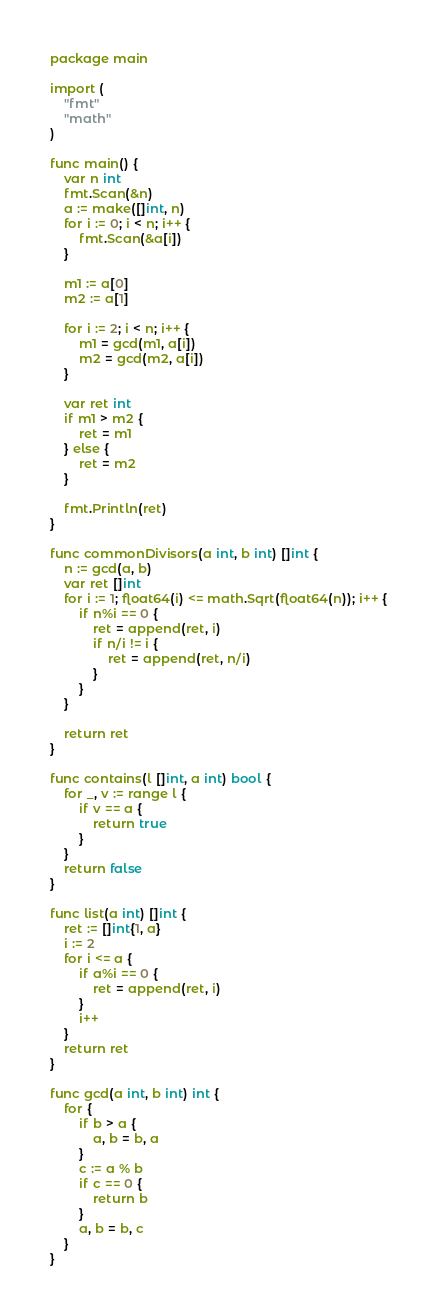<code> <loc_0><loc_0><loc_500><loc_500><_Go_>package main

import (
	"fmt"
	"math"
)

func main() {
	var n int
	fmt.Scan(&n)
	a := make([]int, n)
	for i := 0; i < n; i++ {
		fmt.Scan(&a[i])
	}

	m1 := a[0]
	m2 := a[1]

	for i := 2; i < n; i++ {
		m1 = gcd(m1, a[i])
		m2 = gcd(m2, a[i])
	}

	var ret int
	if m1 > m2 {
		ret = m1
	} else {
		ret = m2
	}

	fmt.Println(ret)
}

func commonDivisors(a int, b int) []int {
	n := gcd(a, b)
	var ret []int
	for i := 1; float64(i) <= math.Sqrt(float64(n)); i++ {
		if n%i == 0 {
			ret = append(ret, i)
			if n/i != i {
				ret = append(ret, n/i)
			}
		}
	}

	return ret
}

func contains(l []int, a int) bool {
	for _, v := range l {
		if v == a {
			return true
		}
	}
	return false
}

func list(a int) []int {
	ret := []int{1, a}
	i := 2
	for i <= a {
		if a%i == 0 {
			ret = append(ret, i)
		}
		i++
	}
	return ret
}

func gcd(a int, b int) int {
	for {
		if b > a {
			a, b = b, a
		}
		c := a % b
		if c == 0 {
			return b
		}
		a, b = b, c
	}
}
</code> 